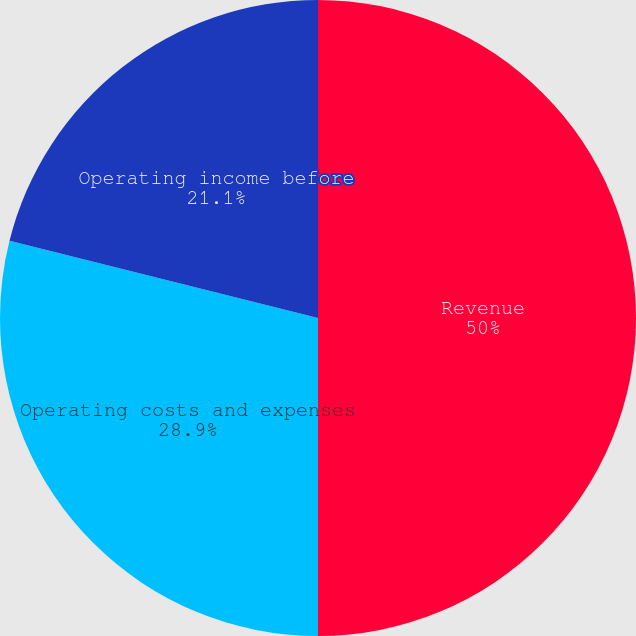Convert chart. <chart><loc_0><loc_0><loc_500><loc_500><pie_chart><fcel>Revenue<fcel>Operating costs and expenses<fcel>Operating income before<nl><fcel>50.0%<fcel>28.9%<fcel>21.1%<nl></chart> 